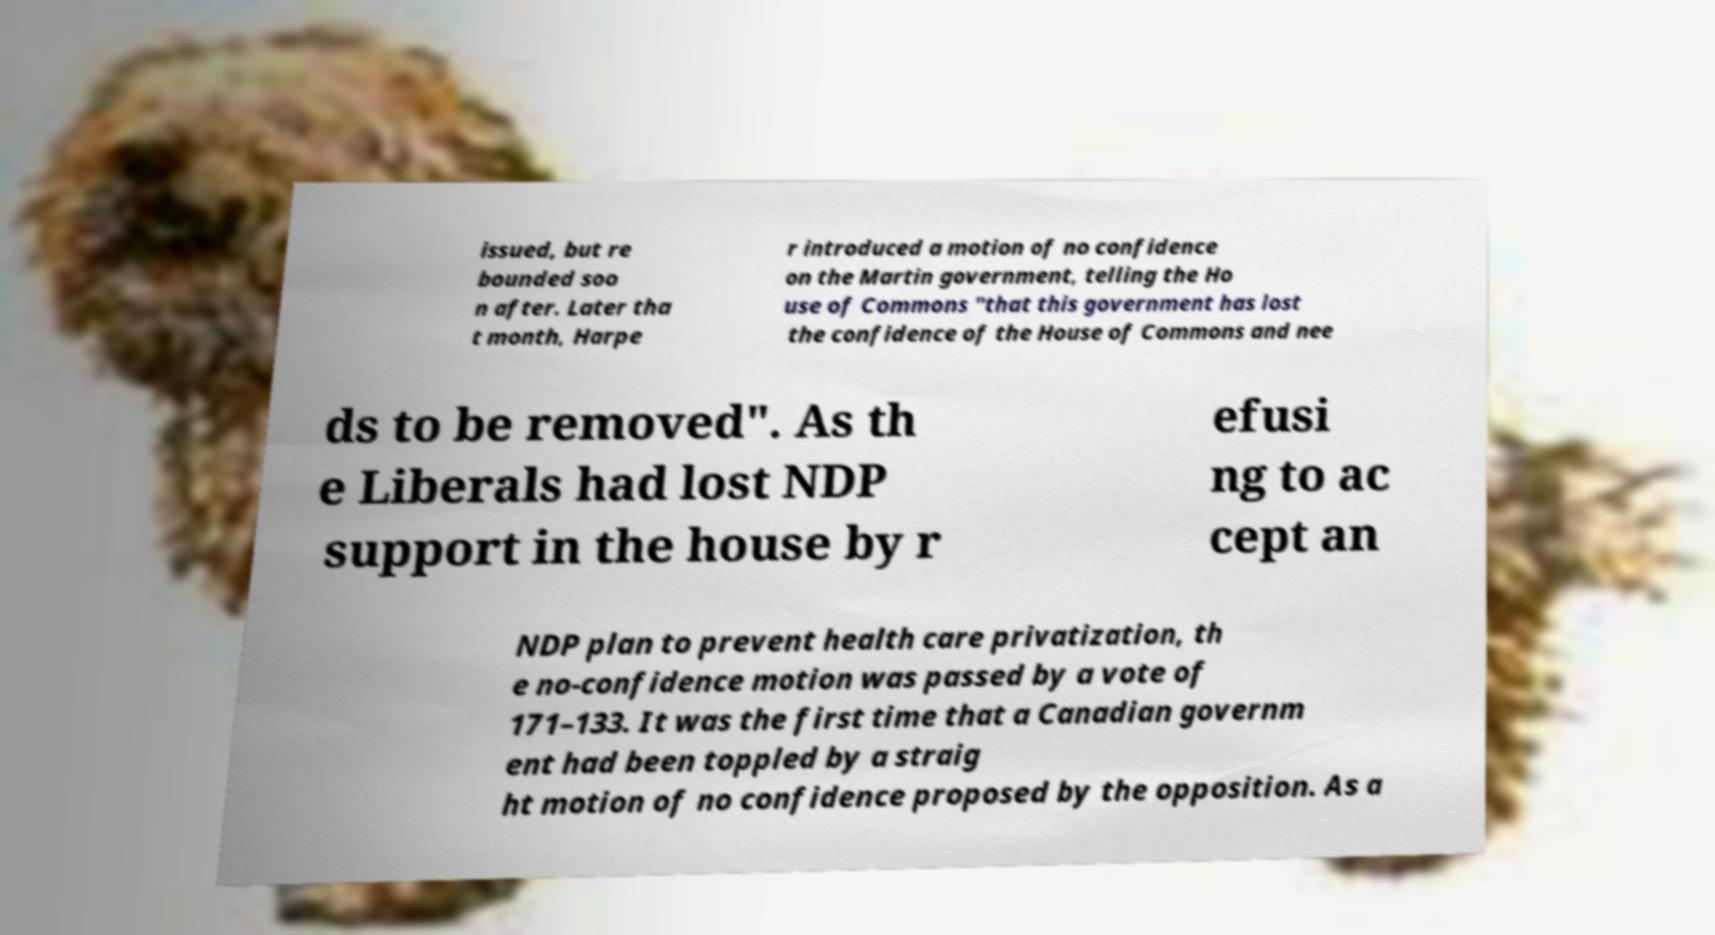Can you accurately transcribe the text from the provided image for me? issued, but re bounded soo n after. Later tha t month, Harpe r introduced a motion of no confidence on the Martin government, telling the Ho use of Commons "that this government has lost the confidence of the House of Commons and nee ds to be removed". As th e Liberals had lost NDP support in the house by r efusi ng to ac cept an NDP plan to prevent health care privatization, th e no-confidence motion was passed by a vote of 171–133. It was the first time that a Canadian governm ent had been toppled by a straig ht motion of no confidence proposed by the opposition. As a 